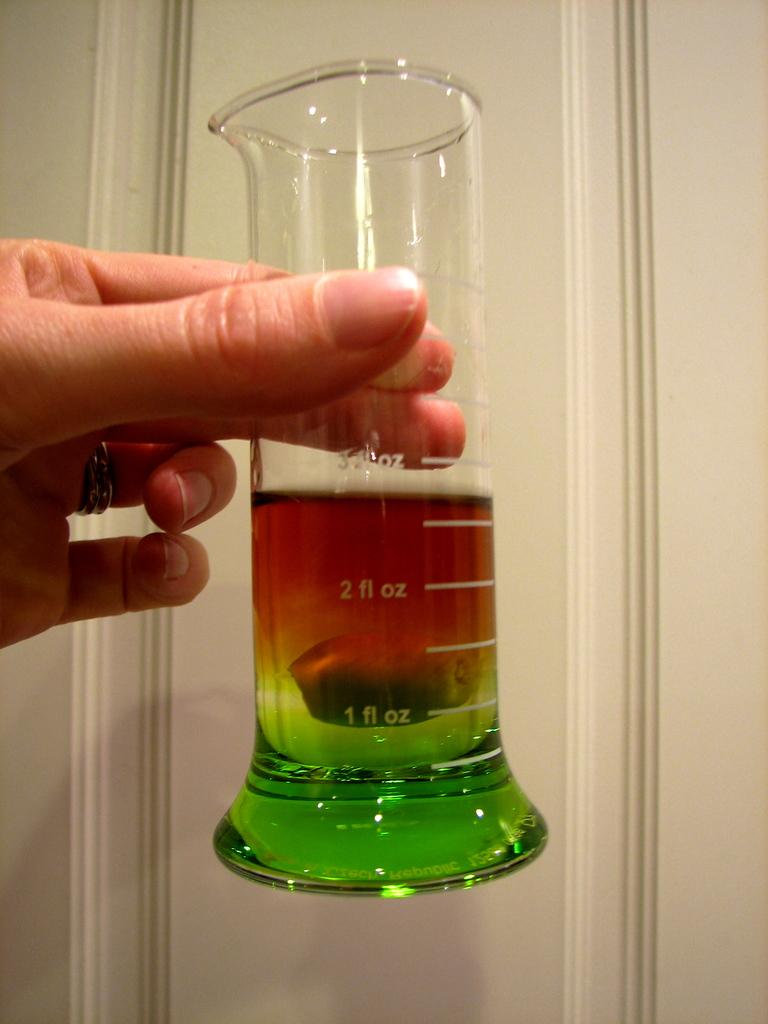<image>
Summarize the visual content of the image. A multi coloured liquid is in a test tube with 2fl oz on it 